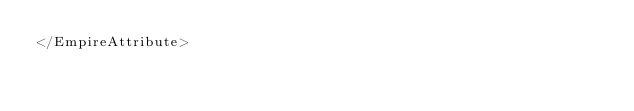<code> <loc_0><loc_0><loc_500><loc_500><_XML_></EmpireAttribute></code> 